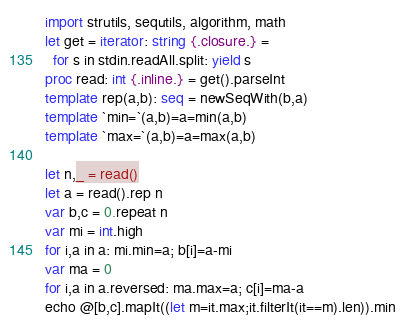<code> <loc_0><loc_0><loc_500><loc_500><_Nim_>import strutils, sequtils, algorithm, math
let get = iterator: string {.closure.} =
  for s in stdin.readAll.split: yield s
proc read: int {.inline.} = get().parseInt
template rep(a,b): seq = newSeqWith(b,a)
template `min=`(a,b)=a=min(a,b)
template `max=`(a,b)=a=max(a,b)

let n,_ = read()
let a = read().rep n
var b,c = 0.repeat n
var mi = int.high
for i,a in a: mi.min=a; b[i]=a-mi
var ma = 0
for i,a in a.reversed: ma.max=a; c[i]=ma-a
echo @[b,c].mapIt((let m=it.max;it.filterIt(it==m).len)).min</code> 